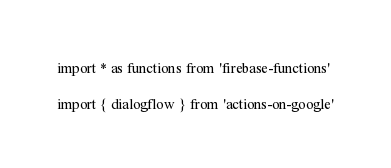<code> <loc_0><loc_0><loc_500><loc_500><_TypeScript_>import * as functions from 'firebase-functions'

import { dialogflow } from 'actions-on-google'</code> 